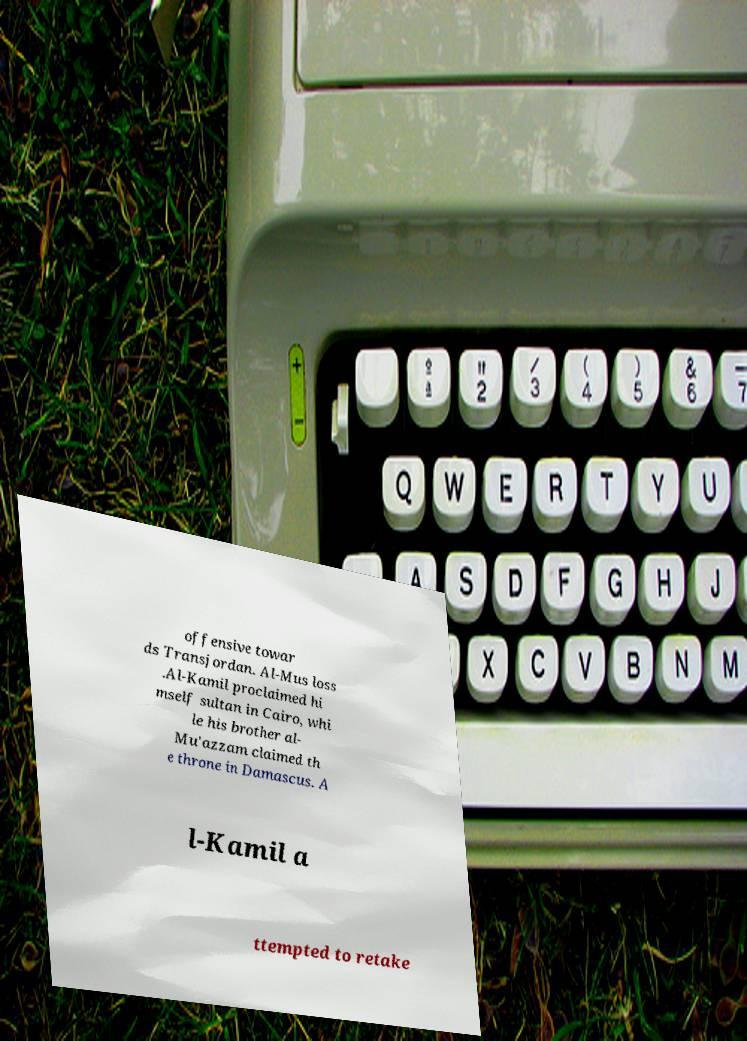Please read and relay the text visible in this image. What does it say? offensive towar ds Transjordan. Al-Mus loss .Al-Kamil proclaimed hi mself sultan in Cairo, whi le his brother al- Mu'azzam claimed th e throne in Damascus. A l-Kamil a ttempted to retake 